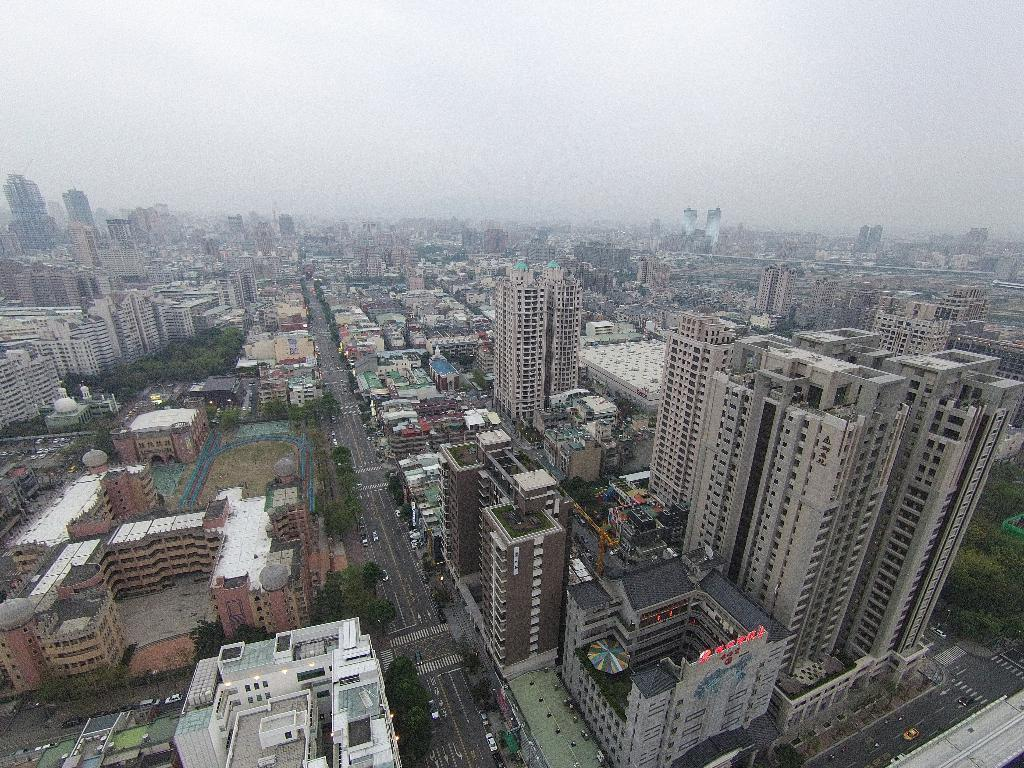What type of structures can be seen in the image? There are many buildings in the image. What other natural elements are present in the image? There are trees in the image. What type of transportation can be seen in the image? There are cars travelling on the road in the image. What is visible in the background of the image? The sky is visible in the image. What type of coastline can be seen in the image? There is no coastline present in the image; it features buildings, trees, cars, and the sky. What part of the body is visible in the image? There are no body parts visible in the image. 